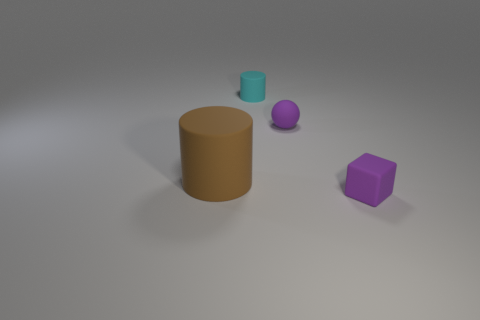How would you interpret the arrangement of the objects in this image? The composition features a large brown cylinder at the center, a smaller teal cylinder to its right, a purple ball, and a purple cube spaced out on an even surface. This deliberate spacing creates a sense of balance and order. It's reminiscent of a minimalist art piece, potentially representing the simplicity and clarity of form. 